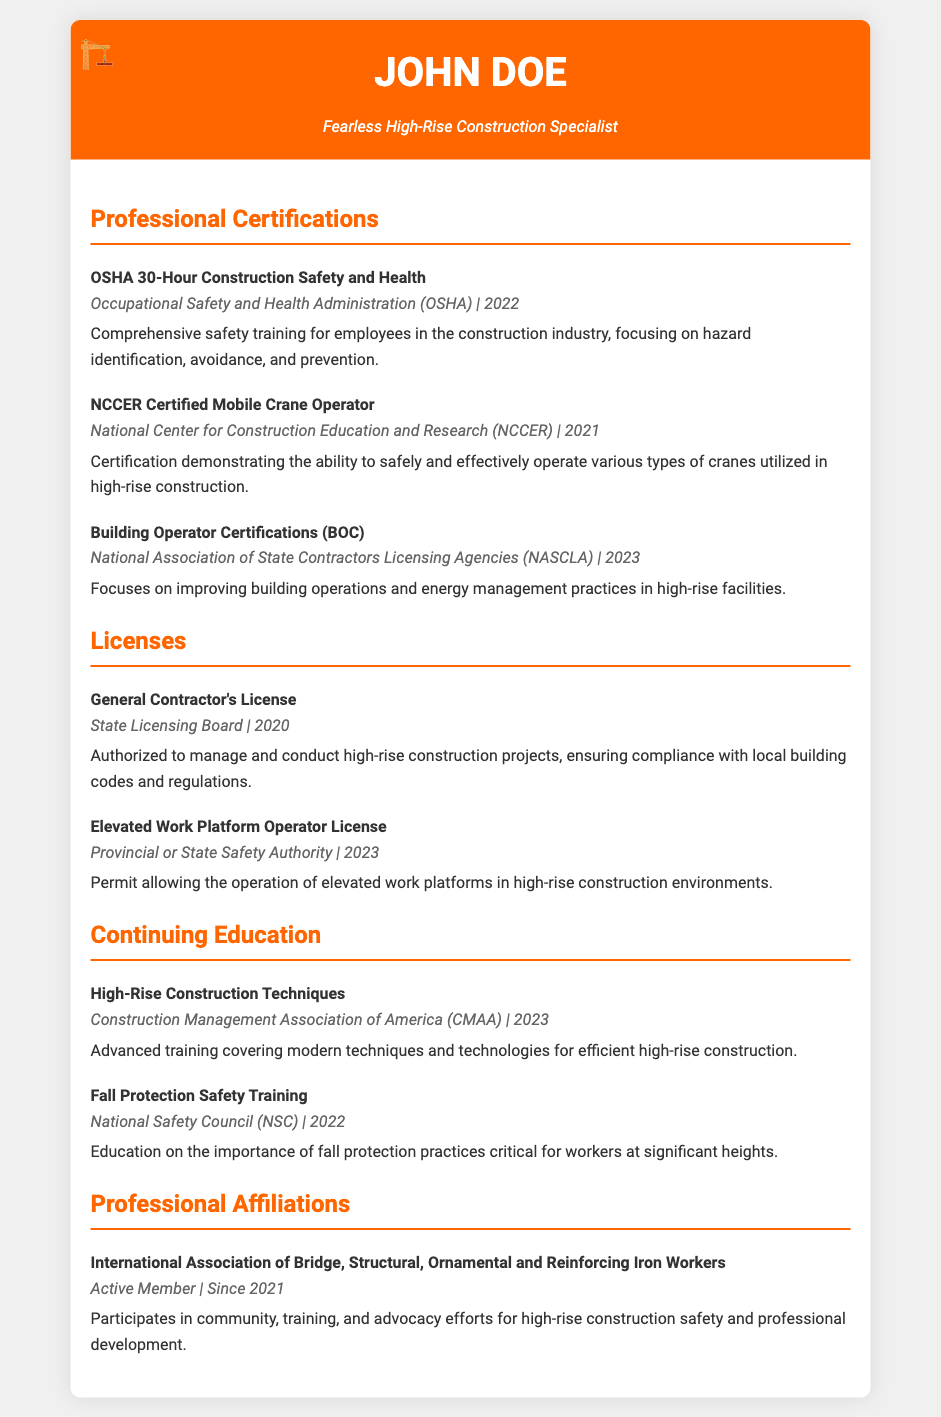What certification was obtained from OSHA? The document specifies that John Doe received the OSHA 30-Hour Construction Safety and Health certification, which is a comprehensive safety training.
Answer: OSHA 30-Hour Construction Safety and Health When was the General Contractor's License issued? The document indicates that the General Contractor's License was issued in the year 2020.
Answer: 2020 Which organization certified the Mobile Crane Operator? The certification for the Mobile Crane Operator was provided by the National Center for Construction Education and Research.
Answer: National Center for Construction Education and Research (NCCER) What is the focus of the Building Operator Certifications? The document describes that the Building Operator Certifications focus on improving building operations and energy management practices in high-rise facilities.
Answer: Improving building operations and energy management practices What year did John Doe become an active member of the International Association of Bridge, Structural, Ornamental and Reinforcing Iron Workers? The document states that John Doe has been an active member since 2021.
Answer: Since 2021 